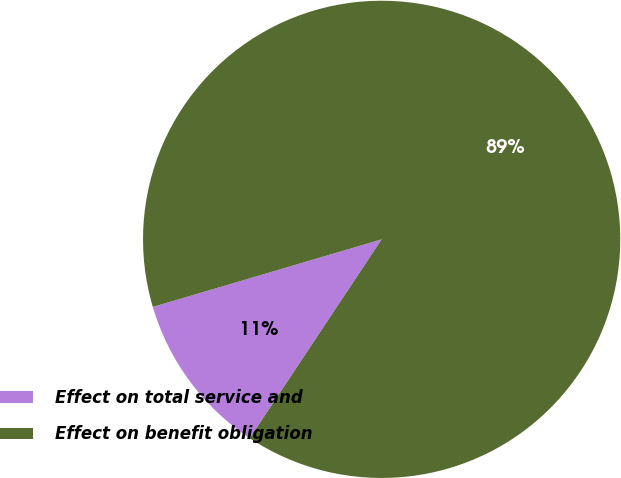Convert chart. <chart><loc_0><loc_0><loc_500><loc_500><pie_chart><fcel>Effect on total service and<fcel>Effect on benefit obligation<nl><fcel>11.11%<fcel>88.89%<nl></chart> 